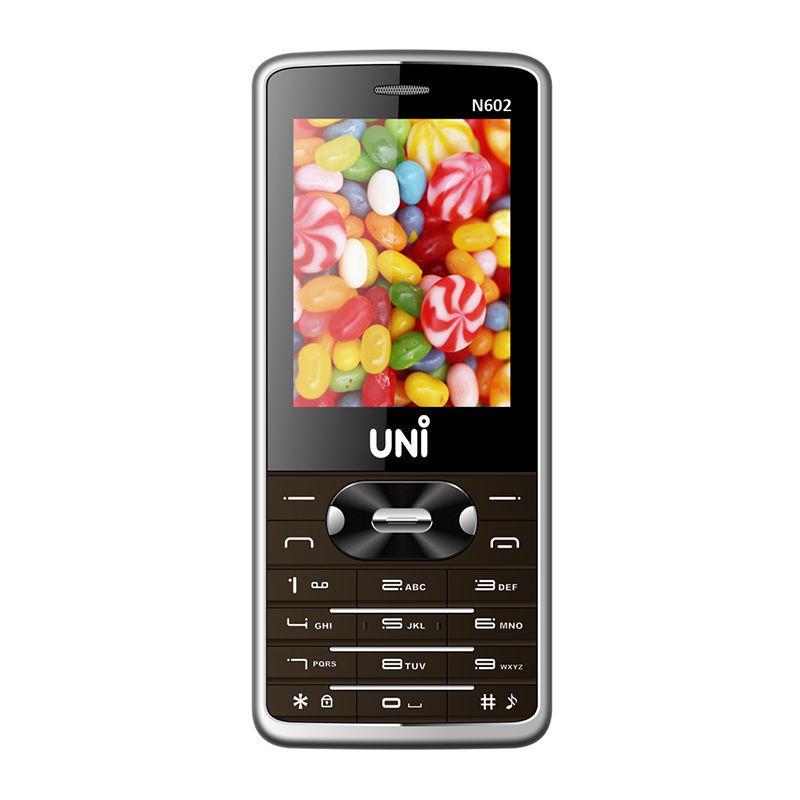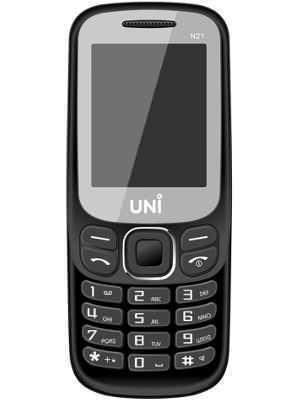The first image is the image on the left, the second image is the image on the right. Given the left and right images, does the statement "The left image shows a side-view of a white phone on the left of a back view of a white phone." hold true? Answer yes or no. No. The first image is the image on the left, the second image is the image on the right. For the images shown, is this caption "Twenty one or more physical buttons are visible." true? Answer yes or no. Yes. 